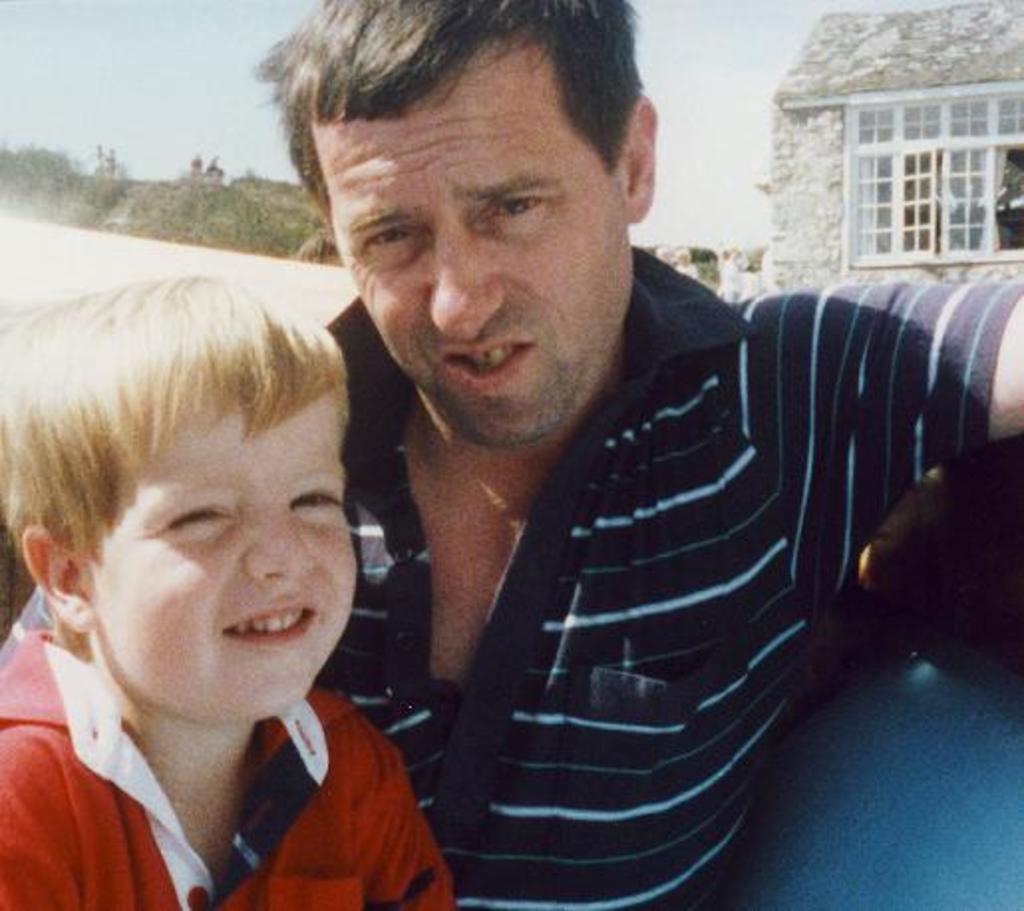Could you give a brief overview of what you see in this image? In this image we can see a man sitting with a child. On the backside we can see some trees, a house with windows and the sky which looks cloudy. 